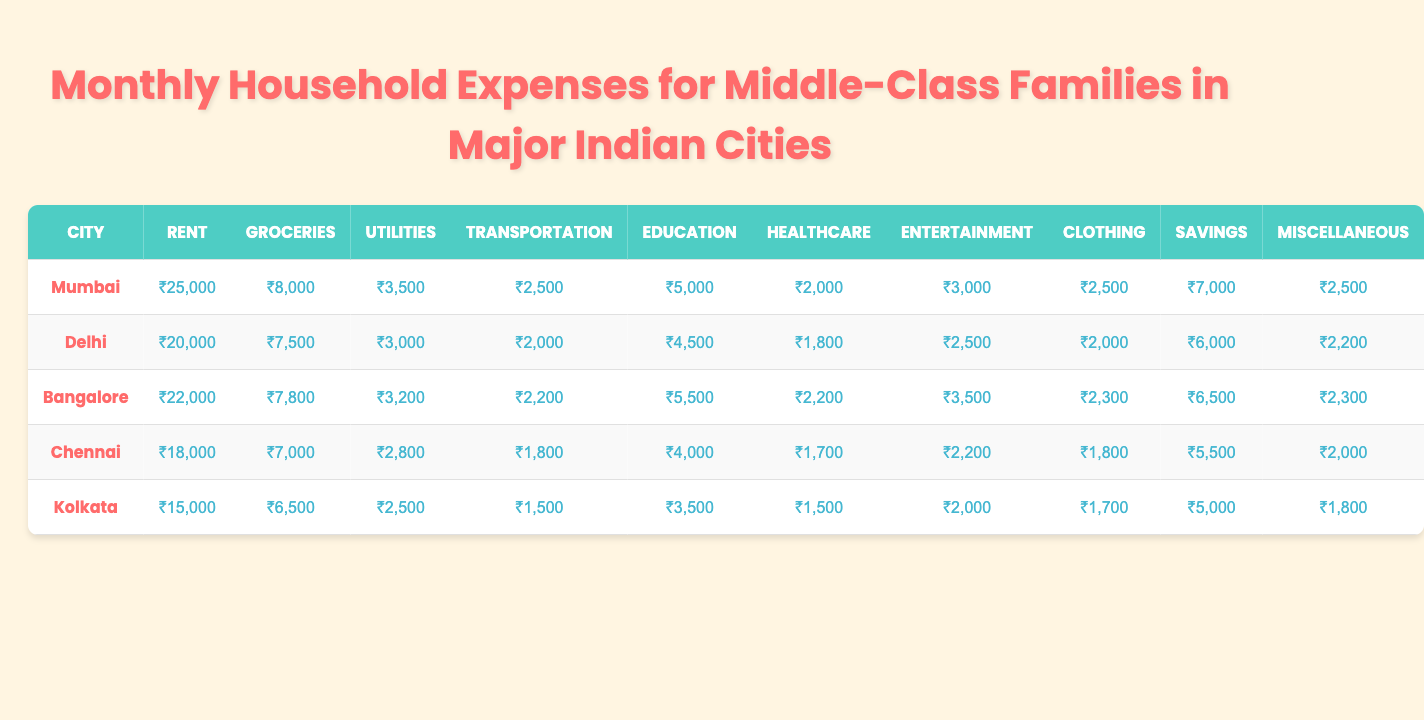What is the monthly rent in Mumbai? The column for the Rent category lists Mumbai with a value of ₹25,000.
Answer: ₹25,000 Which city has the highest monthly expense on groceries? By comparing the Groceries category across all cities, Mumbai has the highest at ₹8,000.
Answer: Mumbai What is the total monthly expenditure on healthcare across all cities? Summing up the Healthcare expenses: (₹2,000 + ₹1,800 + ₹2,200 + ₹1,700 + ₹1,500) gives ₹9,200.
Answer: ₹9,200 Is the monthly entertainment expense the same in Delhi and Chennai? Delhi's entertainment expense is ₹2,500 while Chennai's is ₹2,200; thus they are not the same.
Answer: No Which city has the lowest transportation expense? Kolkata's Transportation expense of ₹1,500 is less than the others, indicating it's the lowest.
Answer: Kolkata What is the difference in savings between Bangalore and Chennai? Savings in Bangalore is ₹6,500 and in Chennai is ₹5,500, so the difference is ₹6,500 - ₹5,500 = ₹1,000.
Answer: ₹1,000 What is the average amount spent on utilities across all cities? Adding all Utilities expenses gives (₹3,500 + ₹3,000 + ₹3,200 + ₹2,800 + ₹2,500) = ₹15,000; dividing by 5 cities results in an average of ₹15,000 / 5 = ₹3,000.
Answer: ₹3,000 Which city spends more on education, Chennai or Kolkata? Chennai spends ₹4,000 on education, while Kolkata spends ₹3,500; thus, Chennai spends more.
Answer: Chennai What percentage of the total household expenses in Mumbai is spent on savings? The total expenses for Mumbai are ₹25,000 + ₹8,000 + ₹3,500 + ₹2,500 + ₹5,000 + ₹2,000 + ₹3,000 + ₹2,500 + ₹7,000 + ₹2,500 = ₹59,500. The savings amount to ₹7,000, so the percentage is (₹7,000 / ₹59,500) * 100 ≈ 11.76%.
Answer: Approximately 11.76% In which category does Kolkata spend the least amount? By looking at the categories, Kolkata spends the least on Clothing at ₹1,700, which is lower than its other expense categories.
Answer: Clothing 